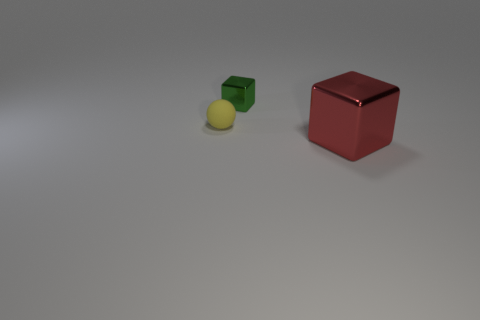Is there anything else that has the same material as the small yellow thing?
Give a very brief answer. No. What material is the cube behind the metal cube that is in front of the block behind the matte thing?
Keep it short and to the point. Metal. How many red things are the same shape as the small yellow thing?
Offer a very short reply. 0. What size is the block that is behind the small thing in front of the small green block?
Your response must be concise. Small. There is a metal cube that is right of the metallic block that is to the left of the large cube; how many big objects are in front of it?
Offer a very short reply. 0. What number of things are in front of the sphere and left of the big red metallic thing?
Keep it short and to the point. 0. Is the number of yellow objects that are to the left of the big red shiny block greater than the number of red rubber things?
Provide a short and direct response. Yes. How many yellow matte objects are the same size as the yellow sphere?
Offer a very short reply. 0. How many large objects are cubes or green cubes?
Your answer should be compact. 1. How many tiny green cylinders are there?
Your response must be concise. 0. 